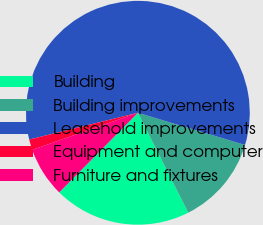Convert chart to OTSL. <chart><loc_0><loc_0><loc_500><loc_500><pie_chart><fcel>Building<fcel>Building improvements<fcel>Leasehold improvements<fcel>Equipment and computer<fcel>Furniture and fixtures<nl><fcel>19.84%<fcel>12.92%<fcel>58.49%<fcel>1.53%<fcel>7.22%<nl></chart> 